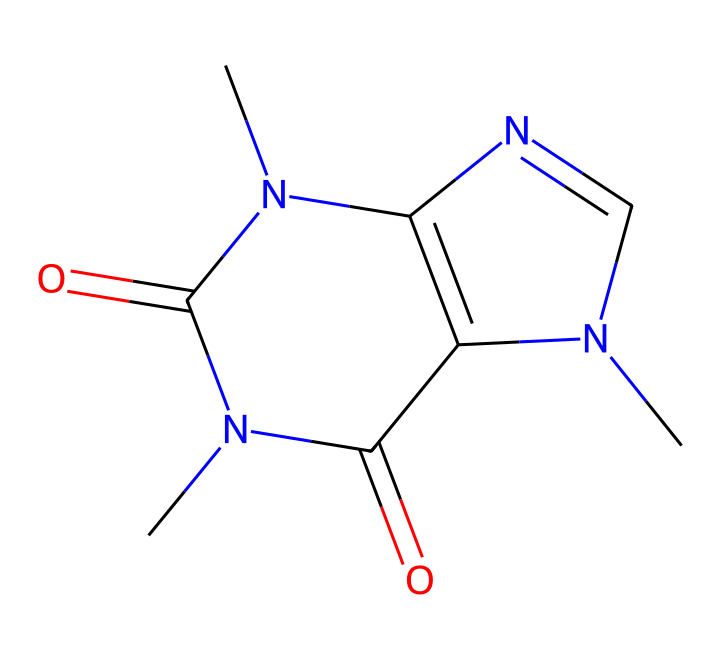What is the molecular formula of caffeine? To determine the molecular formula from the SMILES representation, we count the different types of atoms present. In caffeine, there are carbon (C), nitrogen (N), and oxygen (O) atoms. Counting these results in a molecular formula of C8H10N4O2.
Answer: C8H10N4O2 How many nitrogen atoms are in the caffeine structure? By analyzing the SMILES representation, we identify the nitrogen atoms (N). There are four nitrogen atoms present in the structure.
Answer: 4 What type of compound is caffeine classified as? Caffeine is classified as an alkaloid due to its nitrogen-containing structure, which is characteristic of many natural compounds that exhibit physiological effects.
Answer: alkaloid How many carbon atoms are in caffeine? To find the number of carbon atoms, we can count the number of 'C' in the SMILES representation. There are eight carbon atoms in caffeine.
Answer: 8 What is the primary function of caffeine in coffee? Caffeine primarily functions as a stimulant, which affects the central nervous system, enhancing alertness and reducing fatigue when consumed.
Answer: stimulant Does caffeine dissolve in water? Yes, caffeine is soluble in water due to its polar nature, which allows it to interact with water molecules.
Answer: yes What type of bonding predominates in the structures of non-electrolytes like caffeine? Non-electrolytes, including caffeine, primarily exhibit covalent bonding, which involves the sharing of electron pairs between atoms.
Answer: covalent 